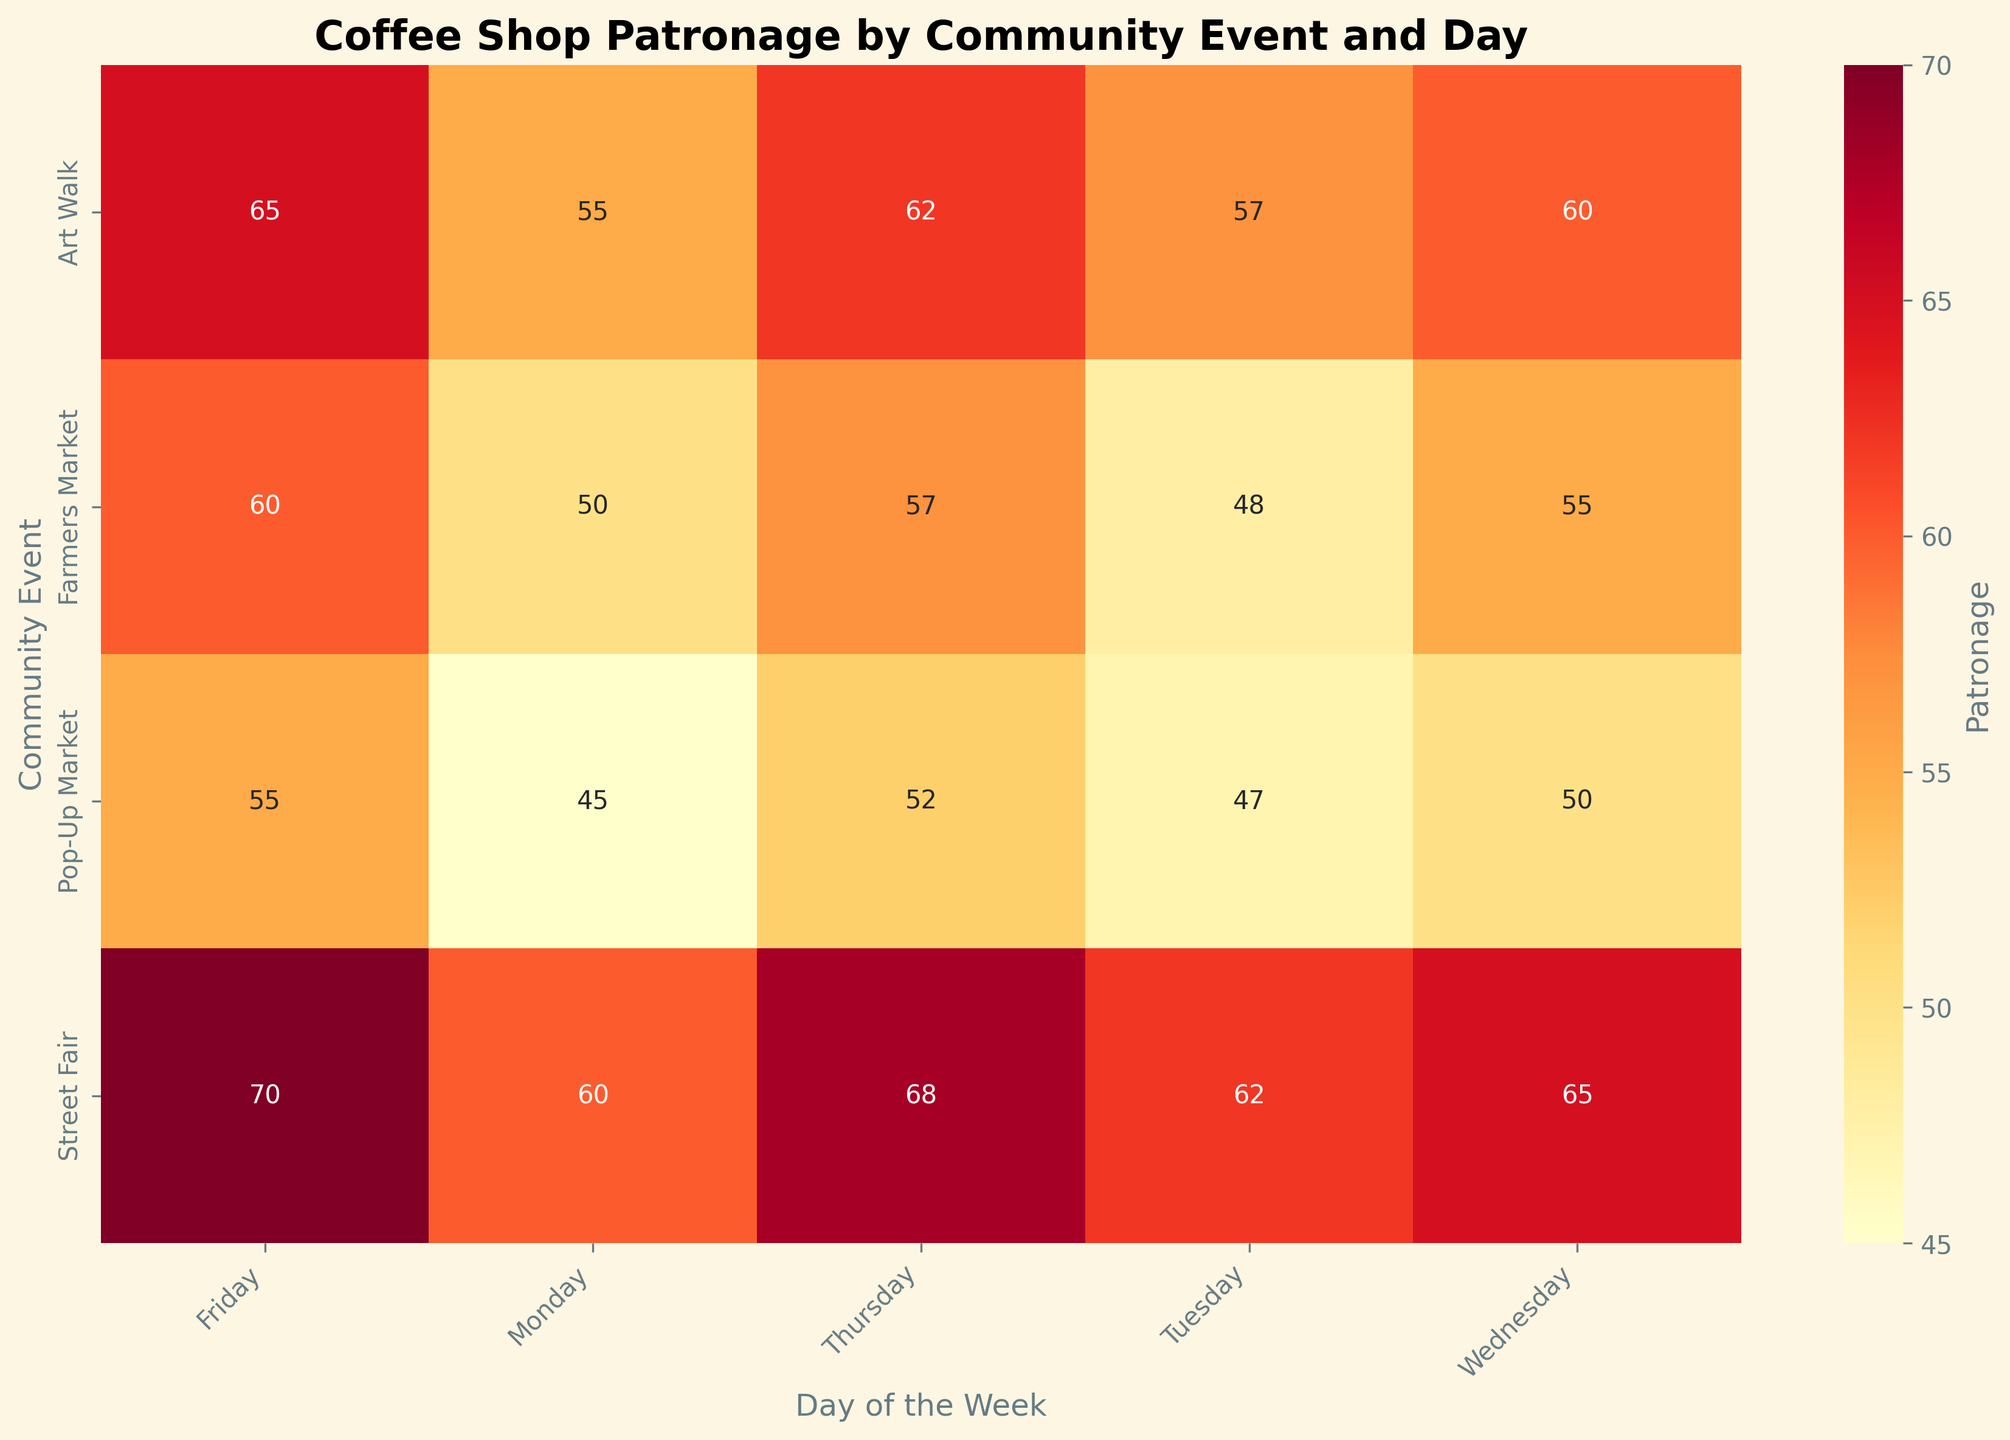What's the title of the heatmap? The title is usually displayed prominently at the top of the heatmap. By identifying it, you can understand what the chart is about.
Answer: Coffee Shop Patronage by Community Event and Day Which day shows the highest patronage for "Flat Black Coffee" during a "Street Fair"? Look for the "Street Fair" row and identify the highest number in that row under the "Flat Black Coffee" column.
Answer: Friday On which day does the "Pop-Up Market" event have the least patronage at "Flat Black Coffee"? Look at the "Pop-Up Market" row and find the smallest number in the "Flat Black Coffee" column.
Answer: Monday What's the average patronage for "Flat Black Coffee" during "Farmers Market" events from Monday to Friday? Add the patronage figures for "Flat Black Coffee" from Monday to Friday during "Farmers Market" and divide by 5. (50 + 48 + 55 + 57 + 60) / 5 = 270 / 5
Answer: 54 Which coffee shop shows the highest patronage on Wednesdays for "Art Walk" events? Find the values for each coffee shop on Wednesdays during "Art Walk" and compare them to see which is the highest.
Answer: Flat Black Coffee Is the patronage higher on Wednesday or Friday for "Flat Black Coffee" during the "Art Walk" event? Compare the patronage values for Wednesdays and Fridays for "Flat Black Coffee" during the "Art Walk" event.
Answer: Friday How does the patronage at "Flat Black Coffee" on Tuesday during "Street Fair" compare to that on Thursday during "Pop-Up Market"? Compare the corresponding values for those specific days and events. Tuesday during "Street Fair" is 62 and Thursday during "Pop-Up Market" is 52.
Answer: Higher on Tuesday during "Street Fair" What is the total patronage at "Flat Black Coffee" across all days during the "Farmers Market"? Add up all the patronage values for "Flat Black Coffee" across all days during "Farmers Market". (50 + 48 + 55 + 57 + 60) = 270
Answer: 270 Which event has the most consistent patronage at "Flat Black Coffee" throughout the week? Compare the variability of patronage values across all days for each event at "Flat Black Coffee". The event with the least variation is considered the most consistent.
Answer: Farmers Market What day of the week tends to show the highest overall patronage for "Flat Black Coffee" across all events? Compare the patronage values for each day of the week across all events at "Flat Black Coffee" to determine which day has the highest sums.
Answer: Friday 